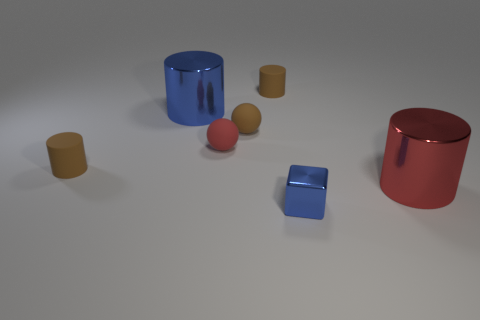Add 2 large metal cylinders. How many objects exist? 9 Subtract all balls. How many objects are left? 5 Subtract all purple metal blocks. Subtract all blue cubes. How many objects are left? 6 Add 6 tiny brown matte things. How many tiny brown matte things are left? 9 Add 5 small purple metal cylinders. How many small purple metal cylinders exist? 5 Subtract 0 blue balls. How many objects are left? 7 